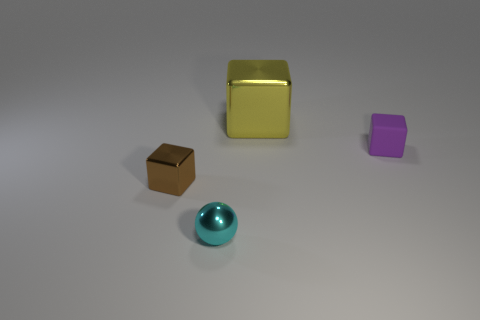Add 3 big cyan balls. How many objects exist? 7 Subtract all blocks. How many objects are left? 1 Subtract all brown things. Subtract all tiny brown objects. How many objects are left? 2 Add 3 cyan balls. How many cyan balls are left? 4 Add 2 large red matte things. How many large red matte things exist? 2 Subtract 0 blue cylinders. How many objects are left? 4 